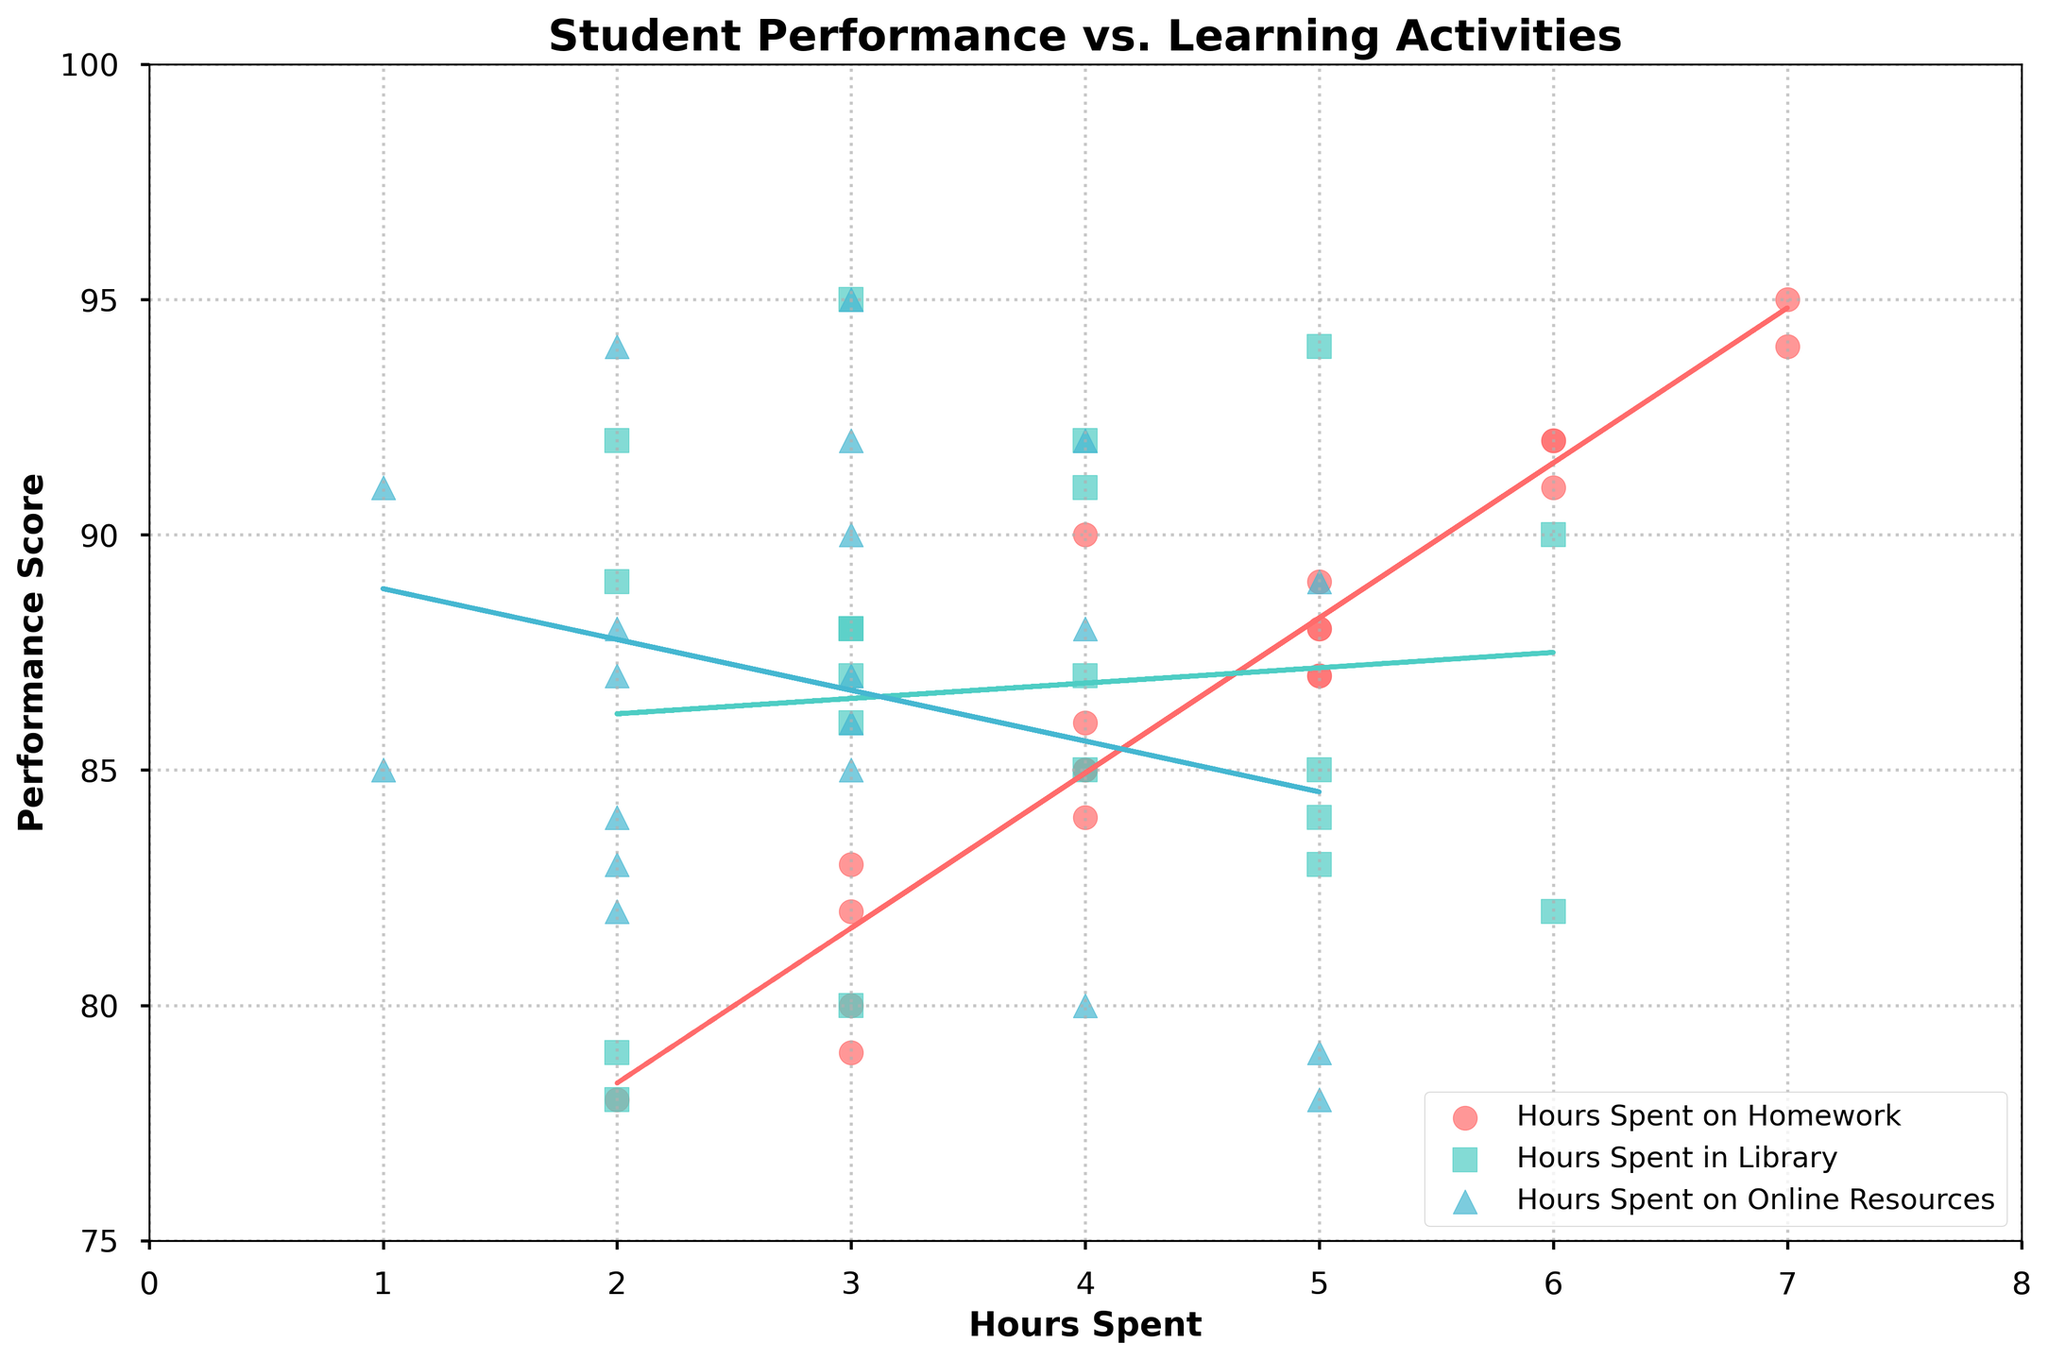What is the title of the figure? The title is displayed at the top of the figure and provides the main subject of the graph. In this case, it reads "Student Performance vs. Learning Activities."
Answer: Student Performance vs. Learning Activities What are the labels on the x-axis and y-axis? The x-axis label is "Hours Spent," indicating the number of hours spent on different learning activities. The y-axis label is "Performance Score," which indicates the student's performance score.
Answer: Hours Spent, Performance Score Which learning activity has the steepest trend line? By visually assessing the slopes of the dashed lines representing the trend lines for each activity, it appears that "Hours Spent on Homework" has the steepest trend line, indicating a strong positive relationship with performance scores.
Answer: Hours Spent on Homework How many different learning activities are represented in the scatter plot, and what are they? There are three different learning activities shown in the scatter plot. They are: "Hours Spent on Homework," "Hours Spent in Library," and "Hours Spent on Online Resources."
Answer: 3; Homework, Library, Online Resources Which learning activity has data points with the highest performance scores? By observing the highest performance scores on the y-axis, "Hours Spent on Homework" has data points reaching up to 95, indicating it consists of the highest performance scores among the three activities.
Answer: Hours Spent on Homework Among the three activities, which one has the most dispersed data points? By examining the spread of the data points, "Hours Spent on Online Resources" has data points spread over a larger performance score range compared to the other activities, indicating higher dispersion.
Answer: Hours Spent on Online Resources What is the range of performance scores represented on the y-axis? The minimum value on the y-axis is 75 and the maximum is 100, providing a range of performance scores from 75 to 100.
Answer: 75 to 100 For "Hours Spent in Library", what is the performance score when the number of hours spent is 2? Follow the vertical line from 2 hours on the x-axis for "Hours Spent in Library" and locate the corresponding performance score. The approximate performance score is around 78.
Answer: Around 78 Comparing the trend lines, which learning activity shows the weakest correlation with performance scores? The trend line for "Hours Spent on Online Resources" appears to be less steep and closer to horizontal compared to the other two activities, indicating a weaker positive correlation with performance scores.
Answer: Hours Spent on Online Resources 